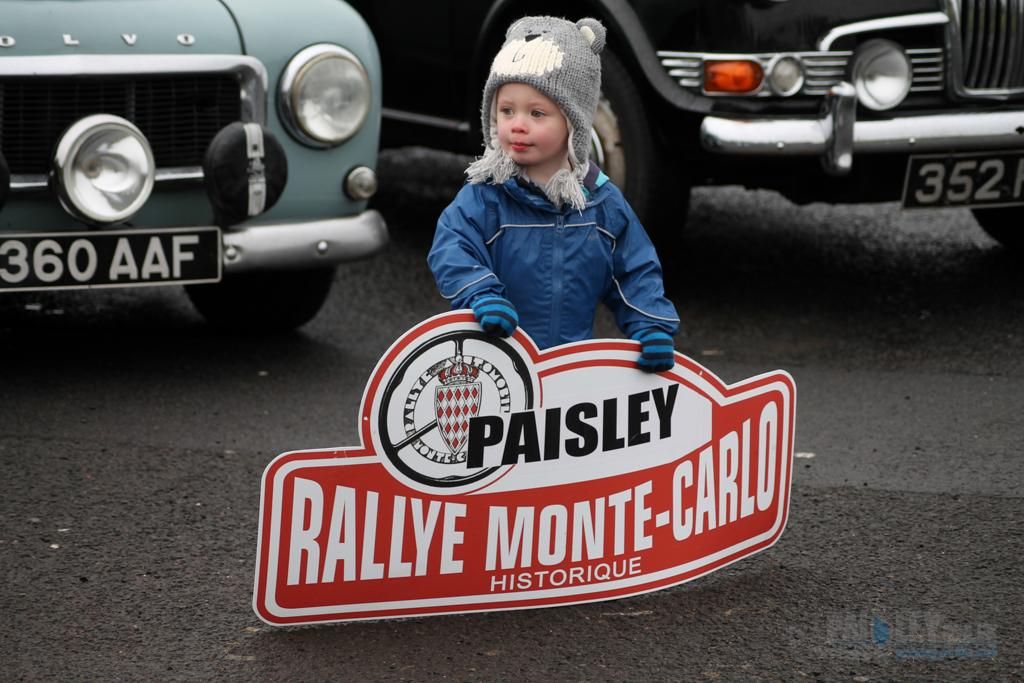What type of vehicles can be seen in the image? There are cars in the image. Who is present in the image besides the cars? There is a girl in the image. What is the girl holding in the image? The girl is holding a banner. What type of dust can be seen on the cars in the image? There is no dust visible on the cars in the image. What advice is the girl giving to the cars in the image? The girl is not giving any advice to the cars in the image; she is simply holding a banner. 